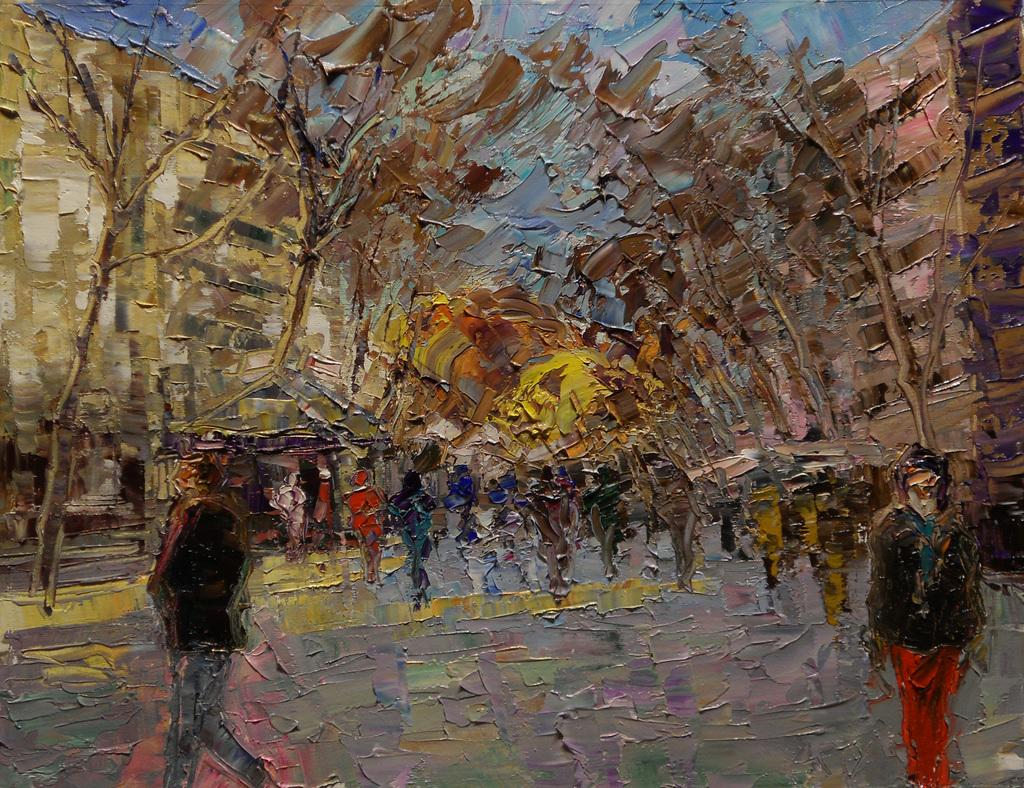What type of artwork is on the wall in the image? There is a water painting on the wall. What subjects are depicted in the water painting? The painting depicts people, trees, buildings, and the sky. How does the visitor interact with the water painting in the image? There is no visitor present in the image, so it is not possible to determine how they might interact with the water painting. 